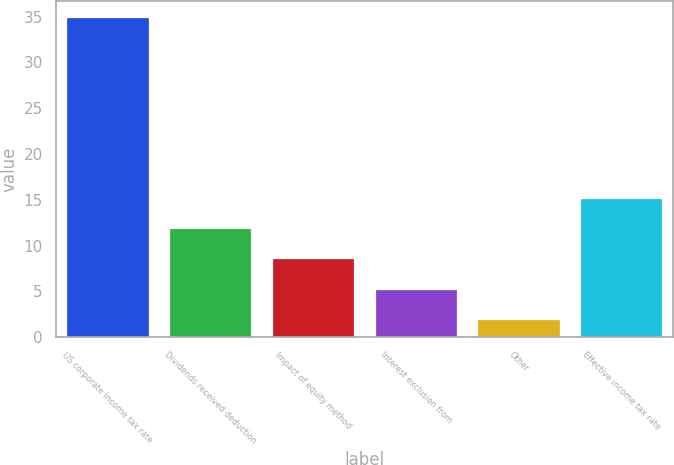<chart> <loc_0><loc_0><loc_500><loc_500><bar_chart><fcel>US corporate income tax rate<fcel>Dividends received deduction<fcel>Impact of equity method<fcel>Interest exclusion from<fcel>Other<fcel>Effective income tax rate<nl><fcel>35<fcel>11.9<fcel>8.6<fcel>5.3<fcel>2<fcel>15.2<nl></chart> 